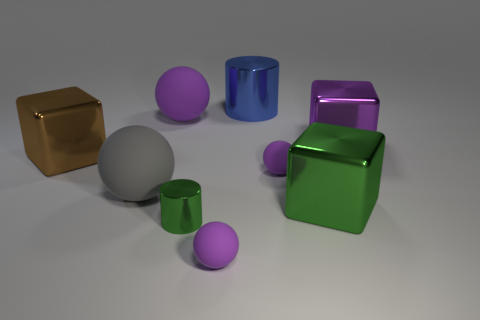Subtract all purple spheres. How many were subtracted if there are1purple spheres left? 2 Subtract all purple cylinders. How many purple spheres are left? 3 Subtract 1 balls. How many balls are left? 3 Add 1 gray rubber objects. How many objects exist? 10 Subtract all cylinders. How many objects are left? 7 Subtract 0 brown balls. How many objects are left? 9 Subtract all big gray balls. Subtract all tiny matte balls. How many objects are left? 6 Add 1 large purple metal things. How many large purple metal things are left? 2 Add 4 big purple shiny things. How many big purple shiny things exist? 5 